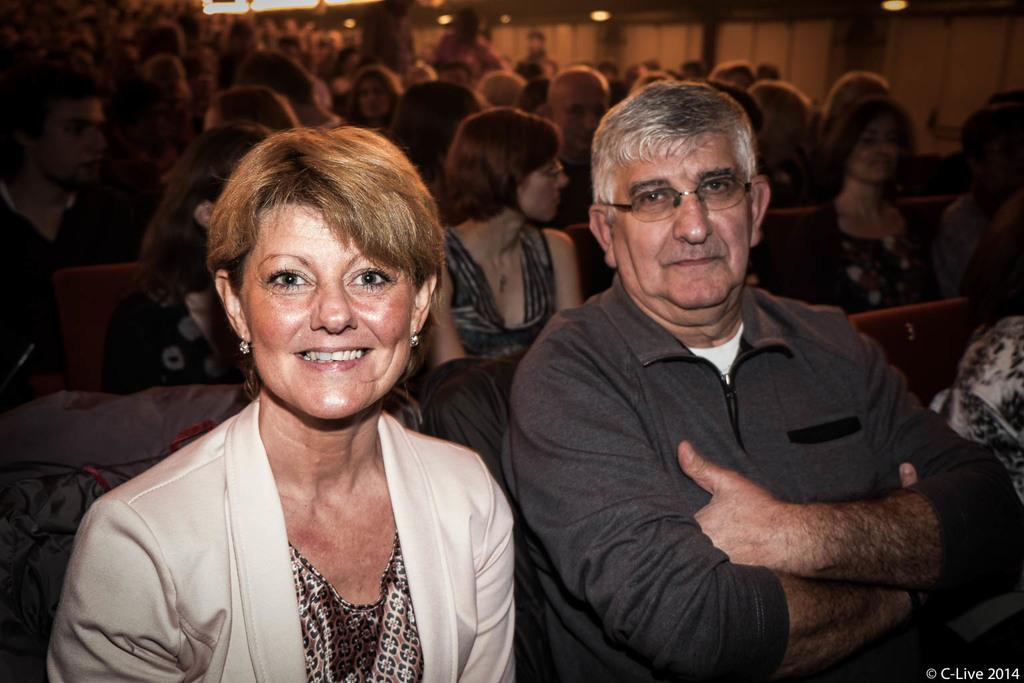What is the main subject of the image? The main subject of the image is a group of people. What objects are present in the image that the people might interact with? There are chairs in the image that the people might sit on. What can be seen in the image that provides illumination? There are lights in the image that provide illumination. What type of cloud can be seen in the image? There is no cloud visible in the image. What type of art is being created by the group of people in the image? The provided facts do not mention any art being created by the group of people in the image. 